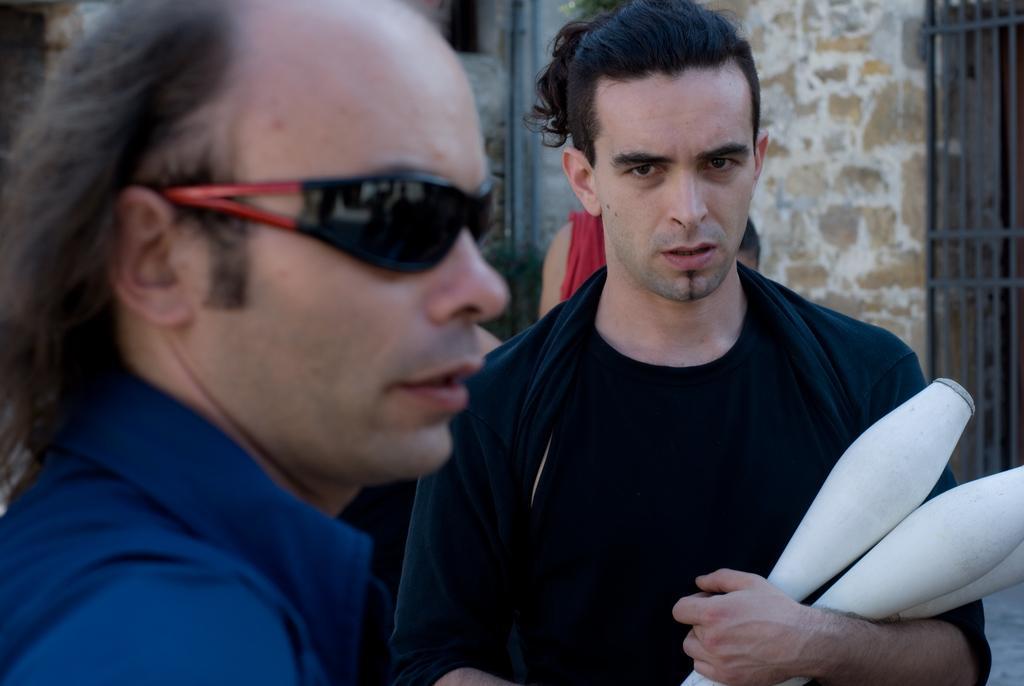Please provide a concise description of this image. In the center of the image we can see a man is standing and holding the objects. On the left side of the image we can see a man is standing and wearing goggles. In the background of the image we can see the wall and grilles. 